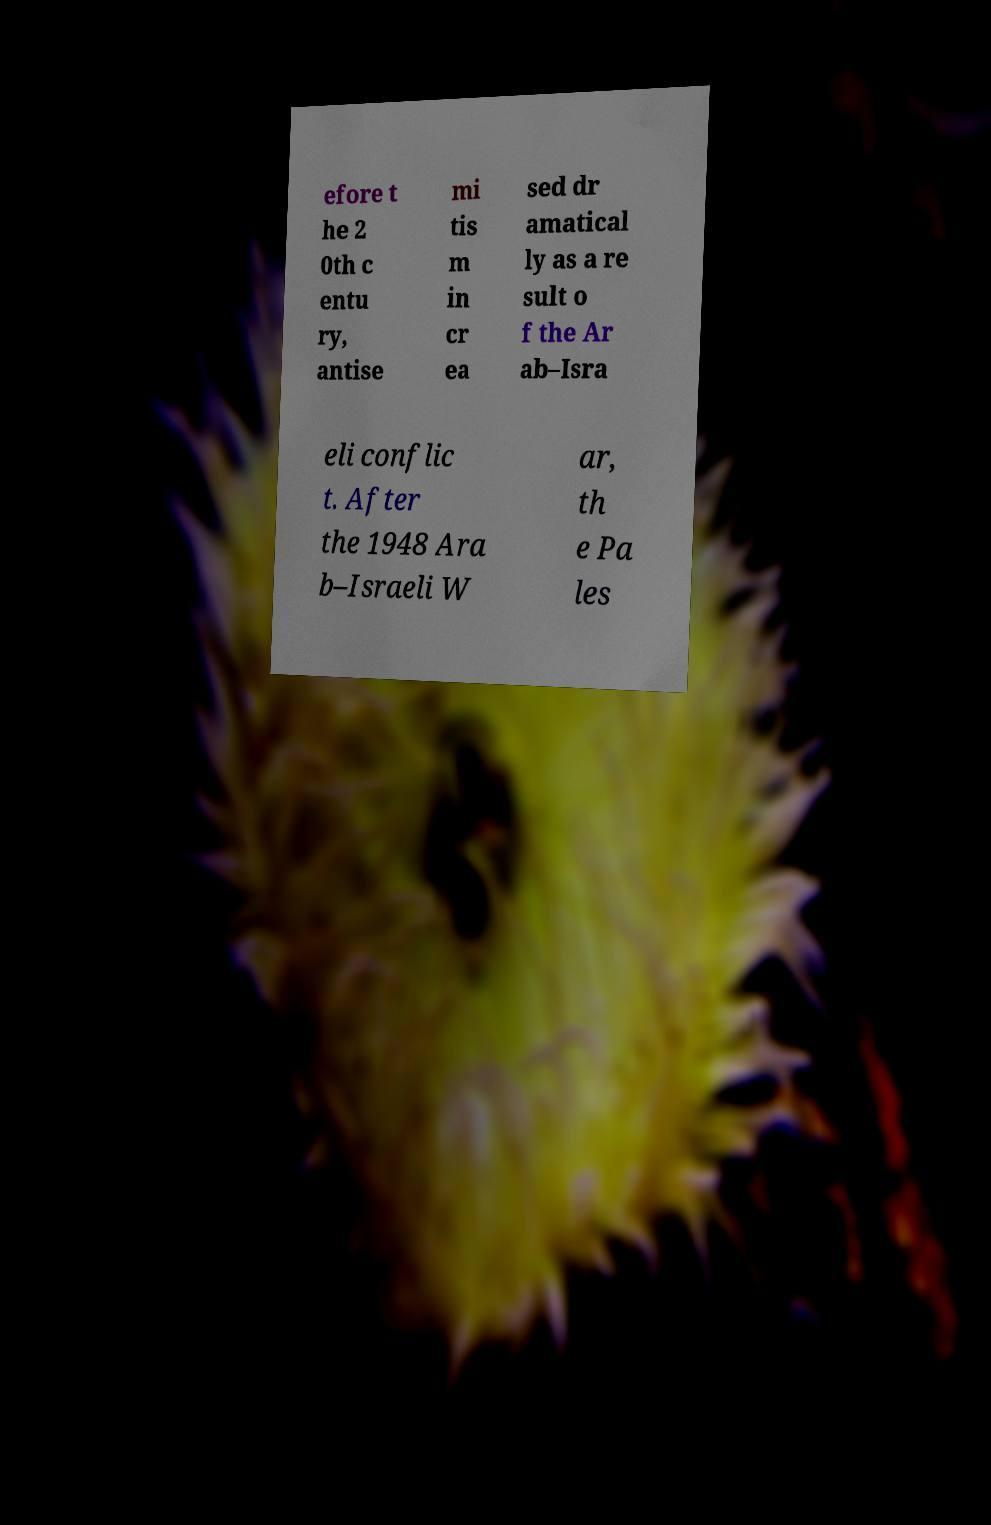Can you accurately transcribe the text from the provided image for me? efore t he 2 0th c entu ry, antise mi tis m in cr ea sed dr amatical ly as a re sult o f the Ar ab–Isra eli conflic t. After the 1948 Ara b–Israeli W ar, th e Pa les 